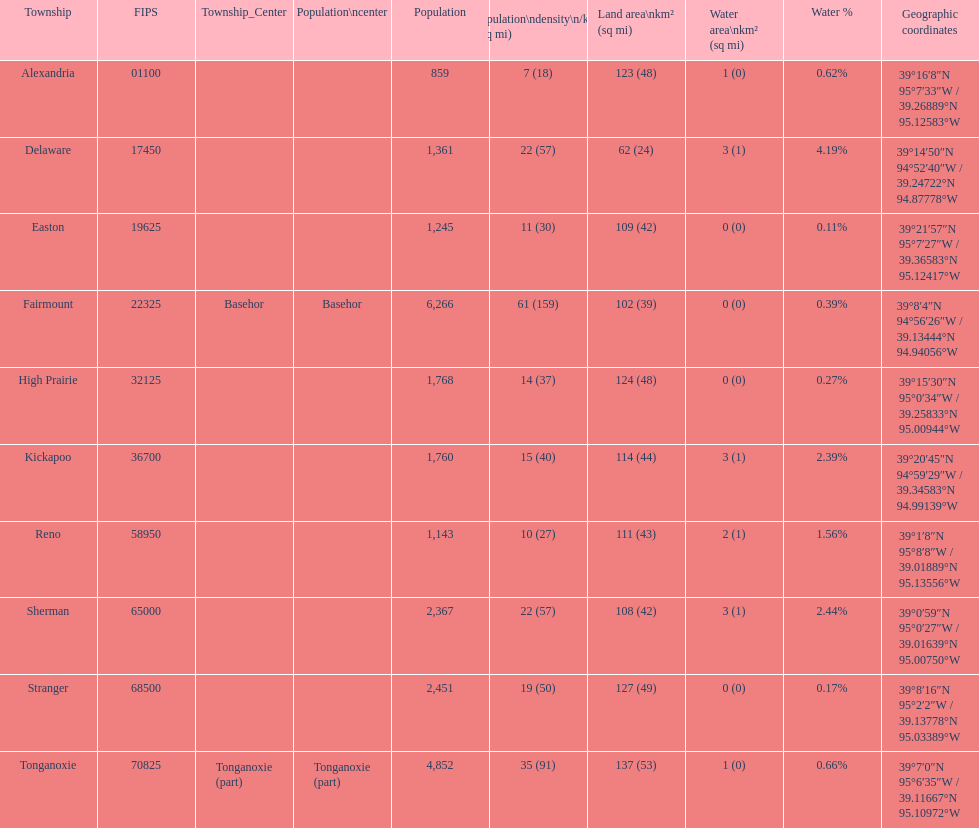What is the difference of population in easton and reno? 102. 